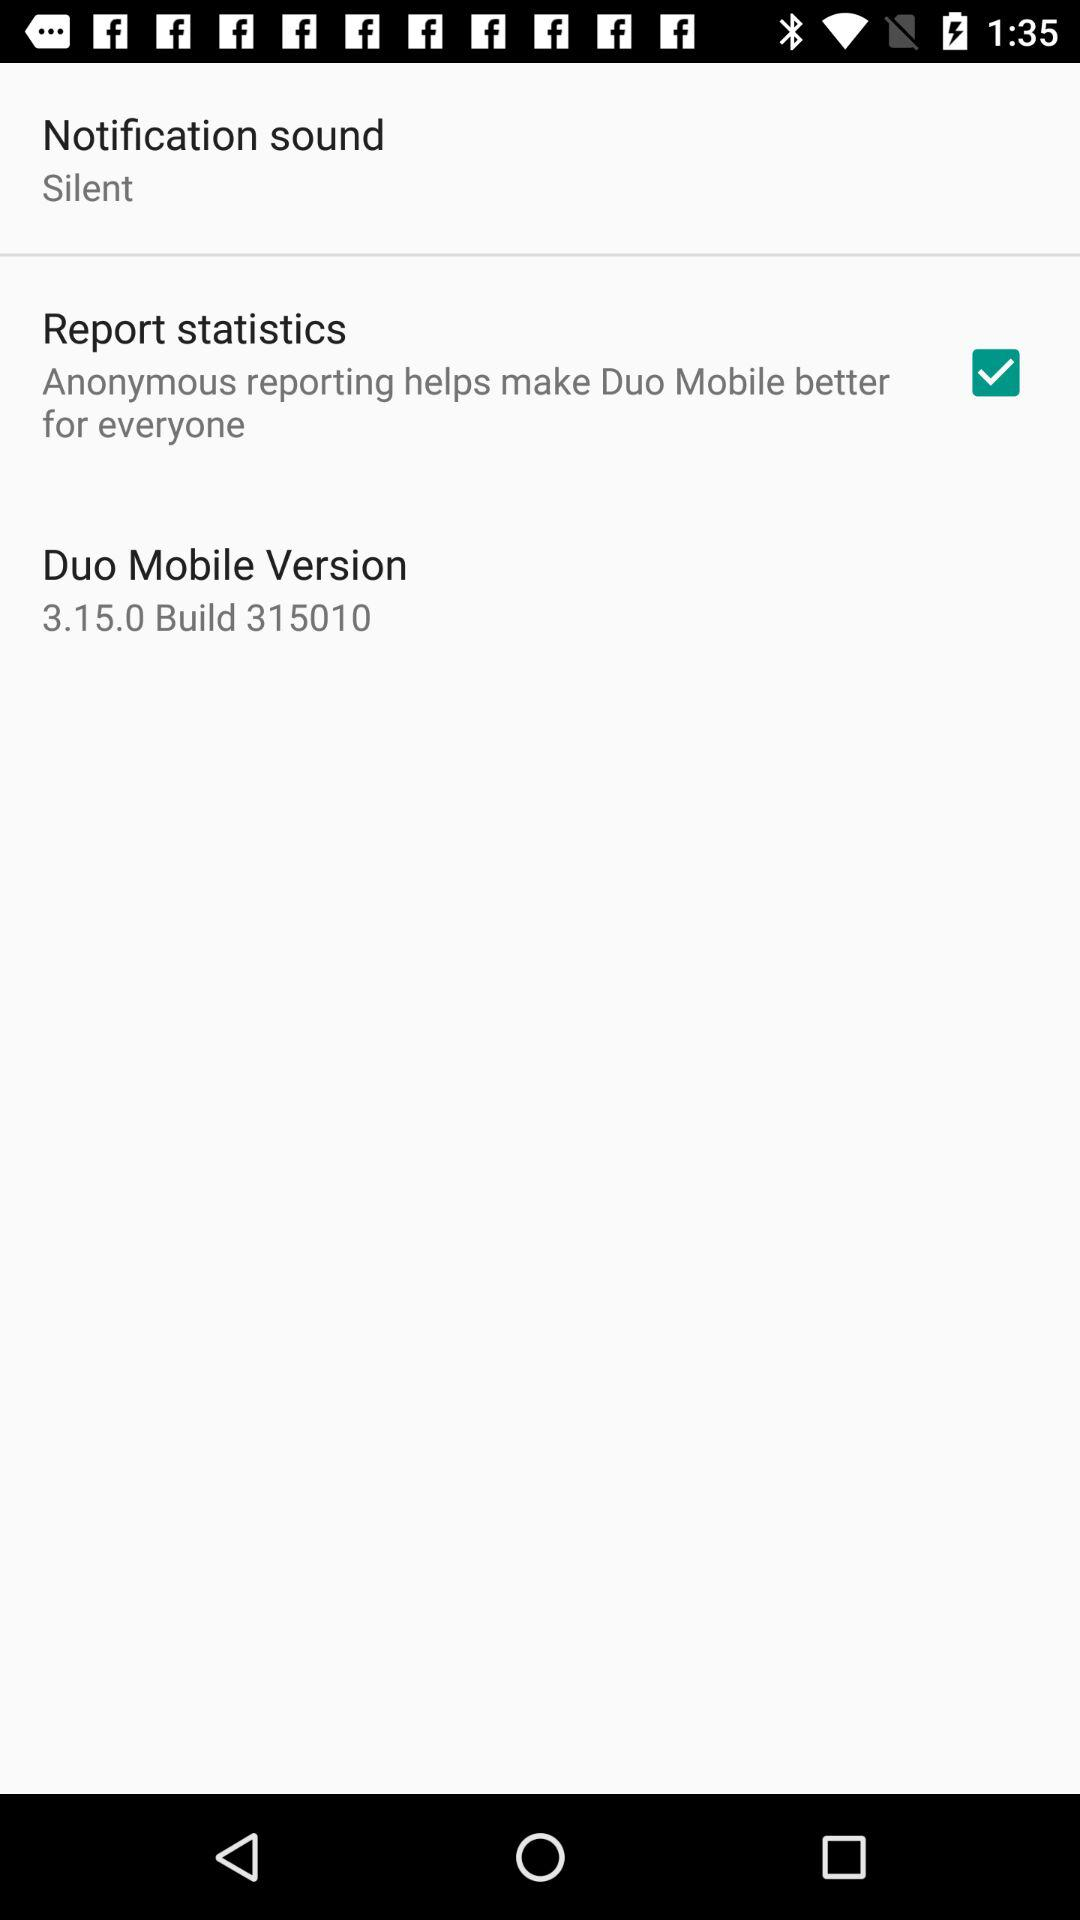What is the status of "Report statistics"? The status of "Report statistics" is "on". 